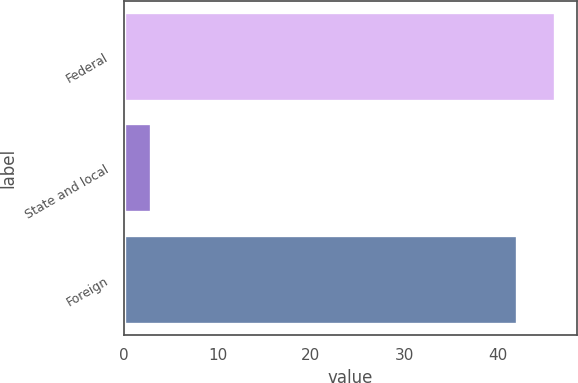<chart> <loc_0><loc_0><loc_500><loc_500><bar_chart><fcel>Federal<fcel>State and local<fcel>Foreign<nl><fcel>46.16<fcel>2.9<fcel>42.1<nl></chart> 